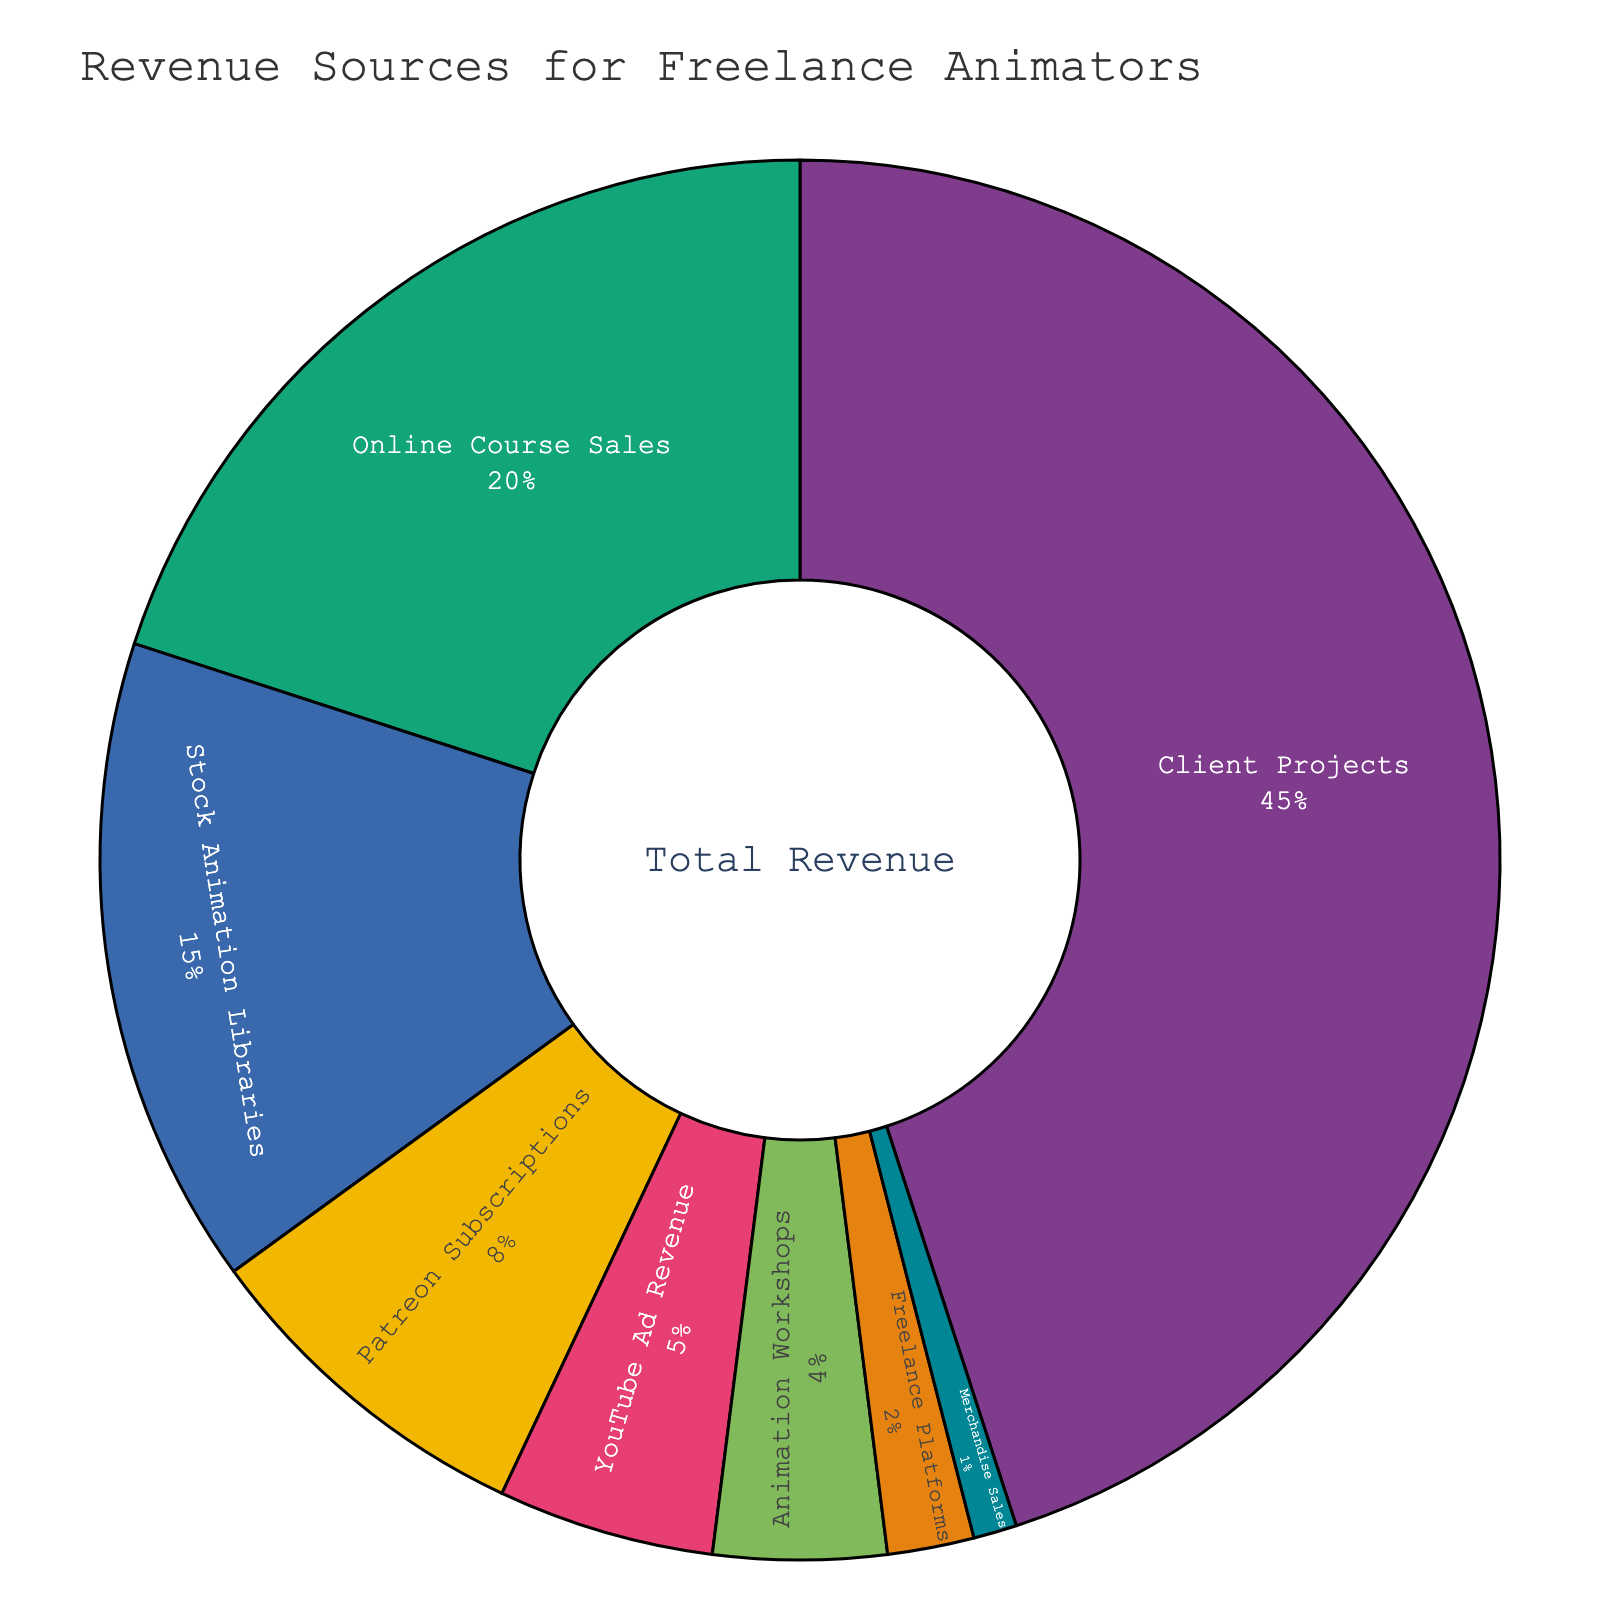What percentage of total revenue comes from client projects and online course sales combined? Client Projects contribute 45% and Online Course Sales contribute 20%. Adding them together, 45 + 20 gives 65%.
Answer: 65% Which revenue source has the second-highest contribution? The highest contribution comes from Client Projects at 45%. The next highest is Online Course Sales at 20%.
Answer: Online Course Sales How do Patreon Subscriptions compare to Stock Animation Libraries in terms of percentage? Stock Animation Libraries contribute 15% while Patreon Subscriptions contribute 8%. 15% is greater than 8%, so Stock Animation Libraries contribute more.
Answer: Stock Animation Libraries contribute more What is the total percentage of revenue from sources that contribute 5% or less each? YouTube Ad Revenue (5%), Animation Workshops (4%), Freelance Platforms (2%), and Merchandise Sales (1%). Adding these together: 5 + 4 + 2 + 1 = 12%.
Answer: 12% Which revenue source has the smallest contribution? According to the data, Merchandise Sales contribute 1%, which is the smallest percentage.
Answer: Merchandise Sales What is the difference in revenue percentage between Client Projects and YouTube Ad Revenue? Client Projects contribute 45%, and YouTube Ad Revenue contributes 5%. The difference is 45 - 5 = 40%.
Answer: 40% Rank the revenue sources from highest to lowest. The revenue sources ranked from highest to lowest are: Client Projects (45%), Online Course Sales (20%), Stock Animation Libraries (15%), Patreon Subscriptions (8%), YouTube Ad Revenue (5%), Animation Workshops (4%), Freelance Platforms (2%), and Merchandise Sales (1%).
Answer: Client Projects, Online Course Sales, Stock Animation Libraries, Patreon Subscriptions, YouTube Ad Revenue, Animation Workshops, Freelance Platforms, Merchandise Sales Which color represents Patreon Subscriptions? By referring to the pie chart, we visually identify the segment associated with Patreon Subscriptions. The specific color used can be identified through the legend or the color-coding of the segment.
Answer: Color (depends on the actual rendered figure) What is the combined percentage of all revenue sources that contribute more than 10% each? Client Projects (45%), Online Course Sales (20%), and Stock Animation Libraries (15%) are above 10%. Adding these together: 45 + 20 + 15 = 80%.
Answer: 80% How much larger is the contribution of Stock Animation Libraries compared to Animation Workshops? Stock Animation Libraries contribute 15%, and Animation Workshops contribute 4%. The difference is 15 - 4 = 11%.
Answer: 11% 